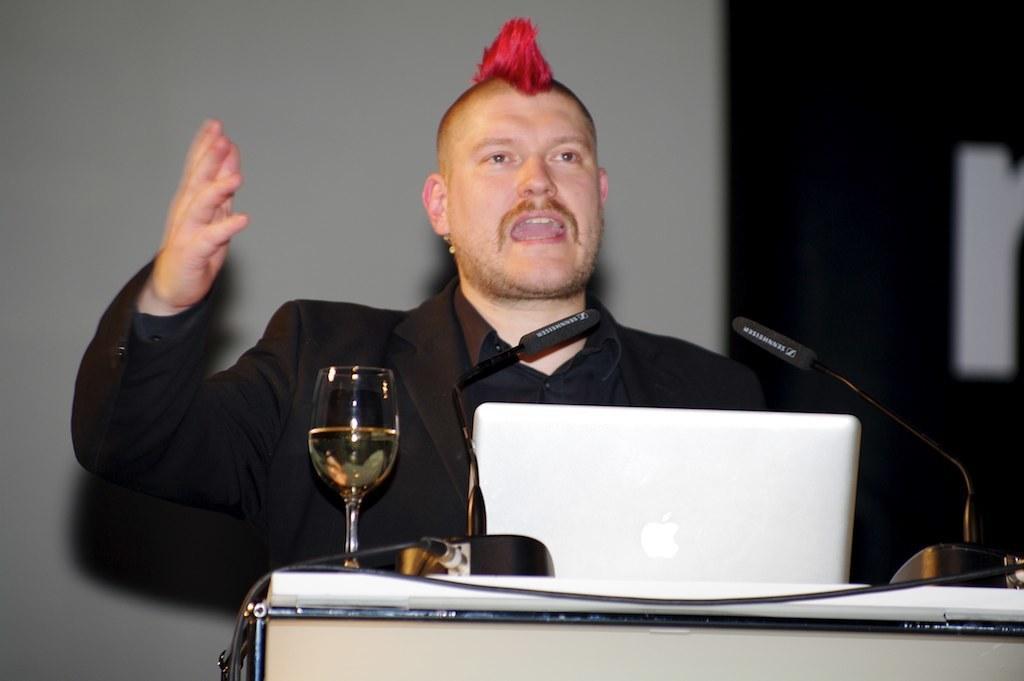Could you give a brief overview of what you see in this image? In this picture there is a man who is standing in the center of the image and there is a desk in front of him, on which there is a laptop, a glass and there are two mics on it. 